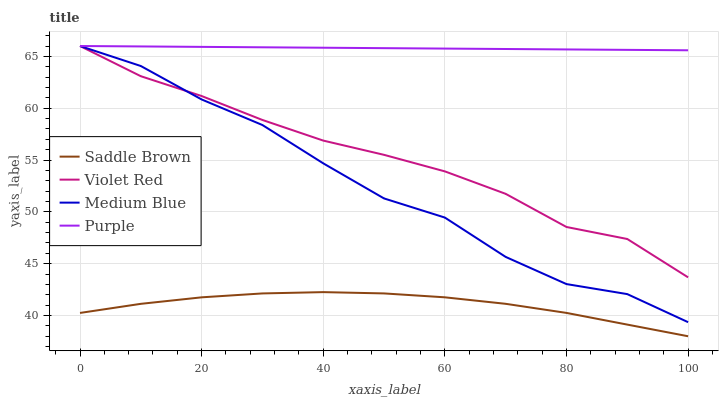Does Saddle Brown have the minimum area under the curve?
Answer yes or no. Yes. Does Purple have the maximum area under the curve?
Answer yes or no. Yes. Does Violet Red have the minimum area under the curve?
Answer yes or no. No. Does Violet Red have the maximum area under the curve?
Answer yes or no. No. Is Purple the smoothest?
Answer yes or no. Yes. Is Medium Blue the roughest?
Answer yes or no. Yes. Is Violet Red the smoothest?
Answer yes or no. No. Is Violet Red the roughest?
Answer yes or no. No. Does Saddle Brown have the lowest value?
Answer yes or no. Yes. Does Violet Red have the lowest value?
Answer yes or no. No. Does Medium Blue have the highest value?
Answer yes or no. Yes. Does Saddle Brown have the highest value?
Answer yes or no. No. Is Saddle Brown less than Medium Blue?
Answer yes or no. Yes. Is Medium Blue greater than Saddle Brown?
Answer yes or no. Yes. Does Purple intersect Medium Blue?
Answer yes or no. Yes. Is Purple less than Medium Blue?
Answer yes or no. No. Is Purple greater than Medium Blue?
Answer yes or no. No. Does Saddle Brown intersect Medium Blue?
Answer yes or no. No. 